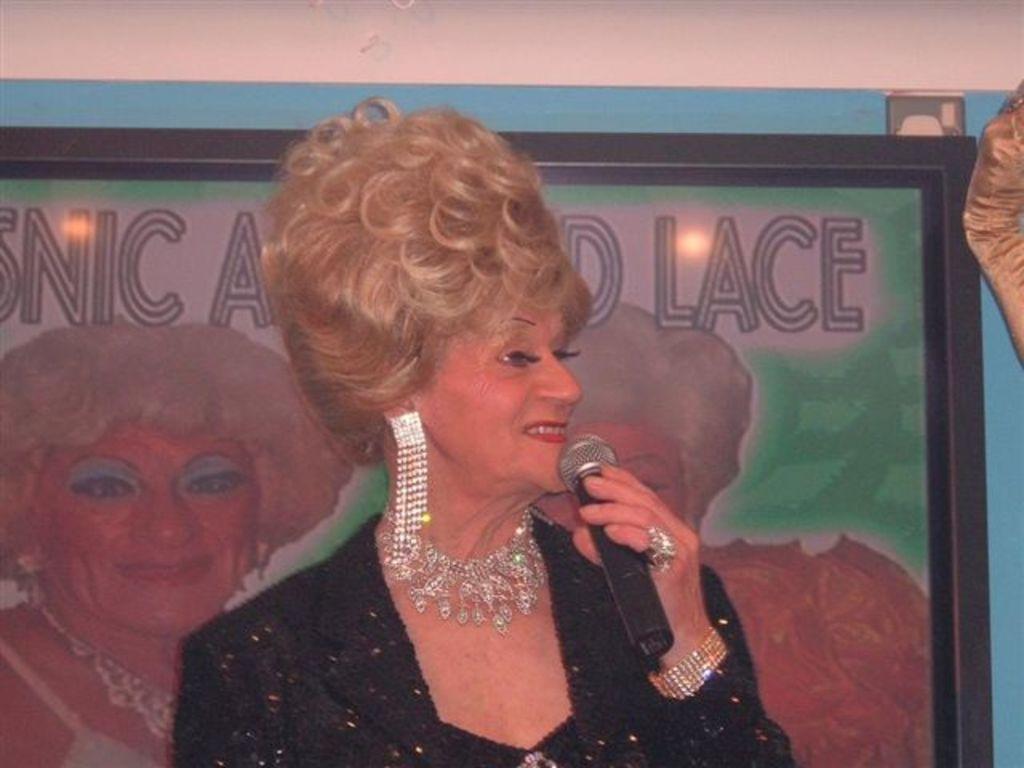Can you describe this image briefly? In this image i can see a woman is holding a microphone and smiling. 